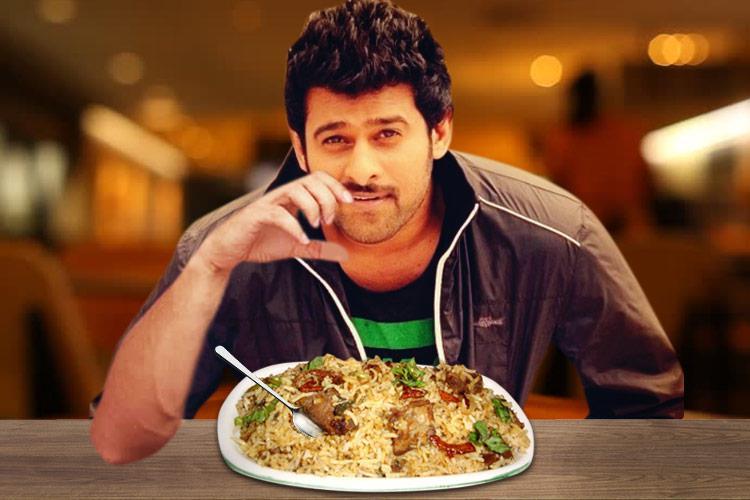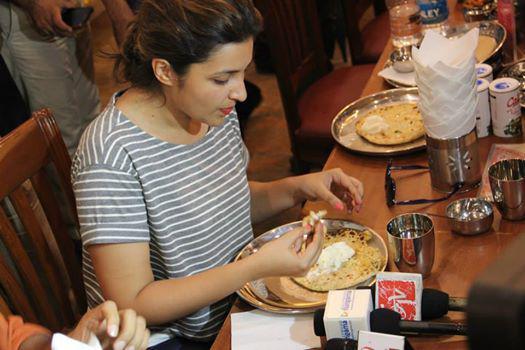The first image is the image on the left, the second image is the image on the right. Assess this claim about the two images: "The left image shows a young man with dark hair on his head and facial hair, sitting behind a table and raising one hand to his mouth.". Correct or not? Answer yes or no. Yes. The first image is the image on the left, the second image is the image on the right. Considering the images on both sides, is "At least one of the pictures shows a person holding a fork or a spoon." valid? Answer yes or no. No. 